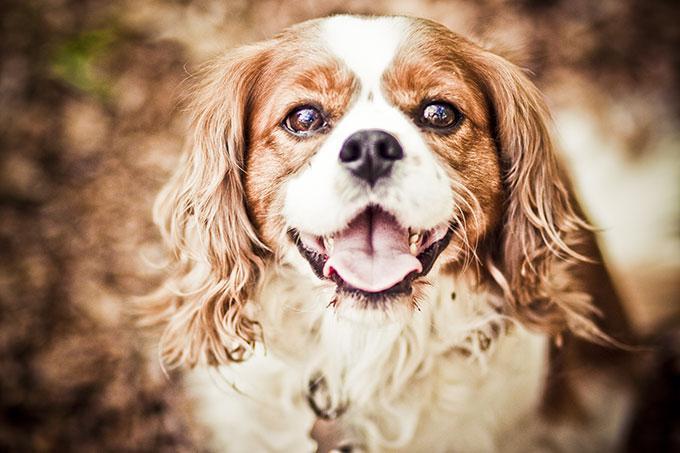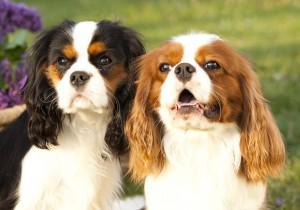The first image is the image on the left, the second image is the image on the right. Evaluate the accuracy of this statement regarding the images: "One image includes twice as many dogs as the other image.". Is it true? Answer yes or no. Yes. The first image is the image on the left, the second image is the image on the right. Considering the images on both sides, is "There are a total of three cocker spaniels" valid? Answer yes or no. Yes. 